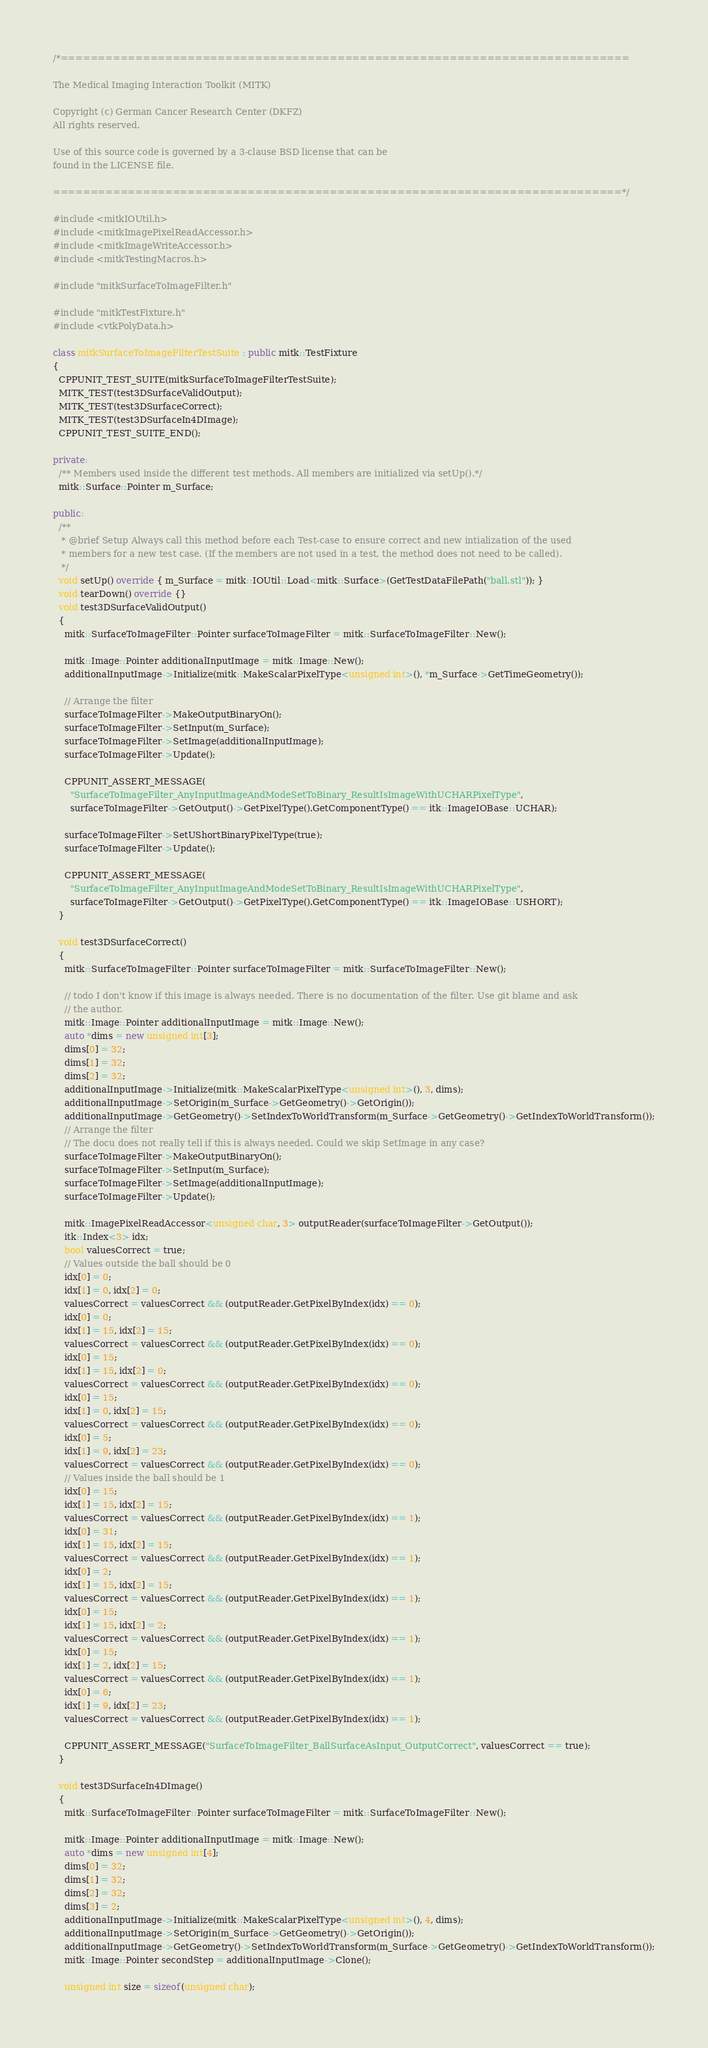<code> <loc_0><loc_0><loc_500><loc_500><_C++_>/*============================================================================

The Medical Imaging Interaction Toolkit (MITK)

Copyright (c) German Cancer Research Center (DKFZ)
All rights reserved.

Use of this source code is governed by a 3-clause BSD license that can be
found in the LICENSE file.

============================================================================*/

#include <mitkIOUtil.h>
#include <mitkImagePixelReadAccessor.h>
#include <mitkImageWriteAccessor.h>
#include <mitkTestingMacros.h>

#include "mitkSurfaceToImageFilter.h"

#include "mitkTestFixture.h"
#include <vtkPolyData.h>

class mitkSurfaceToImageFilterTestSuite : public mitk::TestFixture
{
  CPPUNIT_TEST_SUITE(mitkSurfaceToImageFilterTestSuite);
  MITK_TEST(test3DSurfaceValidOutput);
  MITK_TEST(test3DSurfaceCorrect);
  MITK_TEST(test3DSurfaceIn4DImage);
  CPPUNIT_TEST_SUITE_END();

private:
  /** Members used inside the different test methods. All members are initialized via setUp().*/
  mitk::Surface::Pointer m_Surface;

public:
  /**
   * @brief Setup Always call this method before each Test-case to ensure correct and new intialization of the used
   * members for a new test case. (If the members are not used in a test, the method does not need to be called).
   */
  void setUp() override { m_Surface = mitk::IOUtil::Load<mitk::Surface>(GetTestDataFilePath("ball.stl")); }
  void tearDown() override {}
  void test3DSurfaceValidOutput()
  {
    mitk::SurfaceToImageFilter::Pointer surfaceToImageFilter = mitk::SurfaceToImageFilter::New();

    mitk::Image::Pointer additionalInputImage = mitk::Image::New();
    additionalInputImage->Initialize(mitk::MakeScalarPixelType<unsigned int>(), *m_Surface->GetTimeGeometry());

    // Arrange the filter
    surfaceToImageFilter->MakeOutputBinaryOn();
    surfaceToImageFilter->SetInput(m_Surface);
    surfaceToImageFilter->SetImage(additionalInputImage);
    surfaceToImageFilter->Update();

    CPPUNIT_ASSERT_MESSAGE(
      "SurfaceToImageFilter_AnyInputImageAndModeSetToBinary_ResultIsImageWithUCHARPixelType",
      surfaceToImageFilter->GetOutput()->GetPixelType().GetComponentType() == itk::ImageIOBase::UCHAR);

    surfaceToImageFilter->SetUShortBinaryPixelType(true);
    surfaceToImageFilter->Update();

    CPPUNIT_ASSERT_MESSAGE(
      "SurfaceToImageFilter_AnyInputImageAndModeSetToBinary_ResultIsImageWithUCHARPixelType",
      surfaceToImageFilter->GetOutput()->GetPixelType().GetComponentType() == itk::ImageIOBase::USHORT);
  }

  void test3DSurfaceCorrect()
  {
    mitk::SurfaceToImageFilter::Pointer surfaceToImageFilter = mitk::SurfaceToImageFilter::New();

    // todo I don't know if this image is always needed. There is no documentation of the filter. Use git blame and ask
    // the author.
    mitk::Image::Pointer additionalInputImage = mitk::Image::New();
    auto *dims = new unsigned int[3];
    dims[0] = 32;
    dims[1] = 32;
    dims[2] = 32;
    additionalInputImage->Initialize(mitk::MakeScalarPixelType<unsigned int>(), 3, dims);
    additionalInputImage->SetOrigin(m_Surface->GetGeometry()->GetOrigin());
    additionalInputImage->GetGeometry()->SetIndexToWorldTransform(m_Surface->GetGeometry()->GetIndexToWorldTransform());
    // Arrange the filter
    // The docu does not really tell if this is always needed. Could we skip SetImage in any case?
    surfaceToImageFilter->MakeOutputBinaryOn();
    surfaceToImageFilter->SetInput(m_Surface);
    surfaceToImageFilter->SetImage(additionalInputImage);
    surfaceToImageFilter->Update();

    mitk::ImagePixelReadAccessor<unsigned char, 3> outputReader(surfaceToImageFilter->GetOutput());
    itk::Index<3> idx;
    bool valuesCorrect = true;
    // Values outside the ball should be 0
    idx[0] = 0;
    idx[1] = 0, idx[2] = 0;
    valuesCorrect = valuesCorrect && (outputReader.GetPixelByIndex(idx) == 0);
    idx[0] = 0;
    idx[1] = 15, idx[2] = 15;
    valuesCorrect = valuesCorrect && (outputReader.GetPixelByIndex(idx) == 0);
    idx[0] = 15;
    idx[1] = 15, idx[2] = 0;
    valuesCorrect = valuesCorrect && (outputReader.GetPixelByIndex(idx) == 0);
    idx[0] = 15;
    idx[1] = 0, idx[2] = 15;
    valuesCorrect = valuesCorrect && (outputReader.GetPixelByIndex(idx) == 0);
    idx[0] = 5;
    idx[1] = 9, idx[2] = 23;
    valuesCorrect = valuesCorrect && (outputReader.GetPixelByIndex(idx) == 0);
    // Values inside the ball should be 1
    idx[0] = 15;
    idx[1] = 15, idx[2] = 15;
    valuesCorrect = valuesCorrect && (outputReader.GetPixelByIndex(idx) == 1);
    idx[0] = 31;
    idx[1] = 15, idx[2] = 15;
    valuesCorrect = valuesCorrect && (outputReader.GetPixelByIndex(idx) == 1);
    idx[0] = 2;
    idx[1] = 15, idx[2] = 15;
    valuesCorrect = valuesCorrect && (outputReader.GetPixelByIndex(idx) == 1);
    idx[0] = 15;
    idx[1] = 15, idx[2] = 2;
    valuesCorrect = valuesCorrect && (outputReader.GetPixelByIndex(idx) == 1);
    idx[0] = 15;
    idx[1] = 2, idx[2] = 15;
    valuesCorrect = valuesCorrect && (outputReader.GetPixelByIndex(idx) == 1);
    idx[0] = 6;
    idx[1] = 9, idx[2] = 23;
    valuesCorrect = valuesCorrect && (outputReader.GetPixelByIndex(idx) == 1);

    CPPUNIT_ASSERT_MESSAGE("SurfaceToImageFilter_BallSurfaceAsInput_OutputCorrect", valuesCorrect == true);
  }

  void test3DSurfaceIn4DImage()
  {
    mitk::SurfaceToImageFilter::Pointer surfaceToImageFilter = mitk::SurfaceToImageFilter::New();

    mitk::Image::Pointer additionalInputImage = mitk::Image::New();
    auto *dims = new unsigned int[4];
    dims[0] = 32;
    dims[1] = 32;
    dims[2] = 32;
    dims[3] = 2;
    additionalInputImage->Initialize(mitk::MakeScalarPixelType<unsigned int>(), 4, dims);
    additionalInputImage->SetOrigin(m_Surface->GetGeometry()->GetOrigin());
    additionalInputImage->GetGeometry()->SetIndexToWorldTransform(m_Surface->GetGeometry()->GetIndexToWorldTransform());
    mitk::Image::Pointer secondStep = additionalInputImage->Clone();

    unsigned int size = sizeof(unsigned char);</code> 